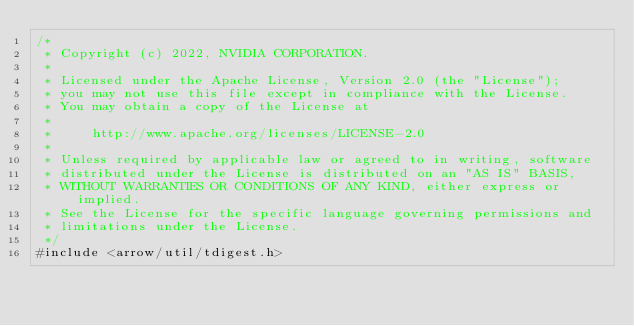<code> <loc_0><loc_0><loc_500><loc_500><_Cuda_>/*
 * Copyright (c) 2022, NVIDIA CORPORATION.
 *
 * Licensed under the Apache License, Version 2.0 (the "License");
 * you may not use this file except in compliance with the License.
 * You may obtain a copy of the License at
 *
 *     http://www.apache.org/licenses/LICENSE-2.0
 *
 * Unless required by applicable law or agreed to in writing, software
 * distributed under the License is distributed on an "AS IS" BASIS,
 * WITHOUT WARRANTIES OR CONDITIONS OF ANY KIND, either express or implied.
 * See the License for the specific language governing permissions and
 * limitations under the License.
 */
#include <arrow/util/tdigest.h>
</code> 